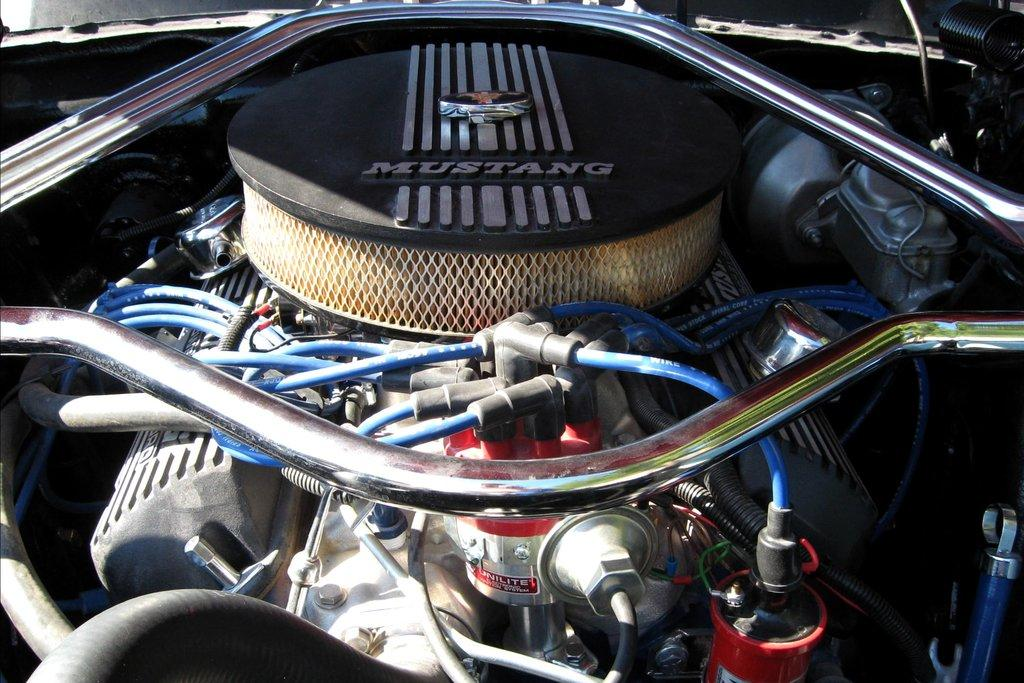What is the main subject of the image? The main subject of the image is the engine of a car. What color are the pipes visible in the image? The pipes in the image are blue. What type of material is used for the rods inside the engine? The rods inside the engine are made of metal. What type of ship can be seen sailing in the background of the image? There is no ship visible in the image; it only contains the engine of a car. 